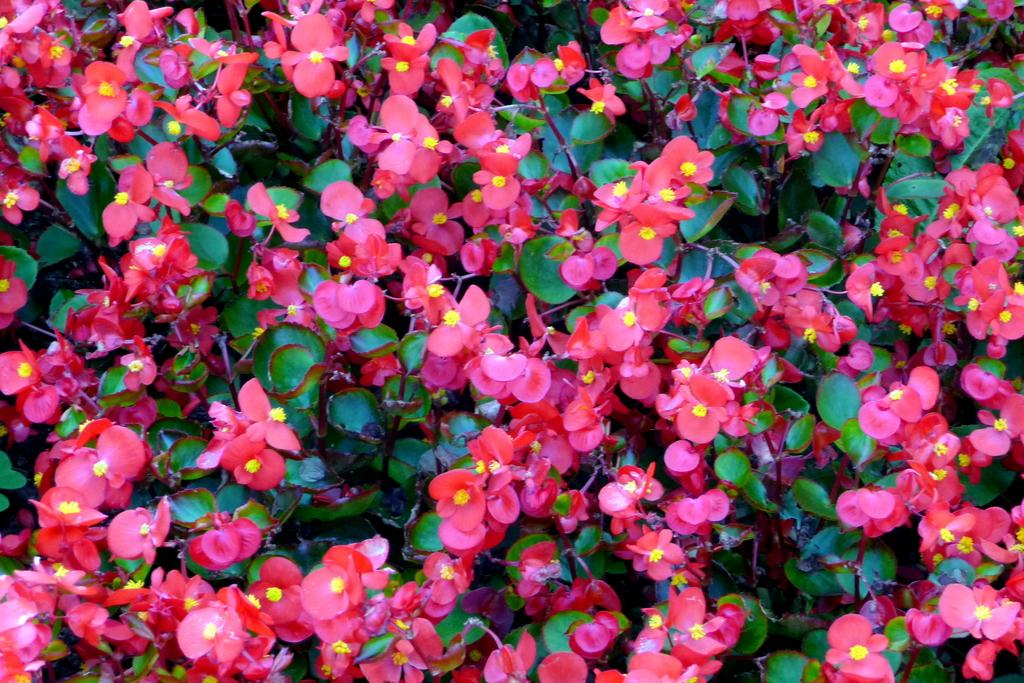What type of plant life is visible in the image? There are flowers, leaves, and branches visible in the image. Can you describe the specific parts of the plants that are present in the image? The flowers, leaves, and branches are the main parts of the plants that are visible in the image. What type of bread can be seen being used as a chess piece in the image? There is no bread or chess pieces present in the image. What type of pipe is visible in the image? There is no pipe present in the image. 